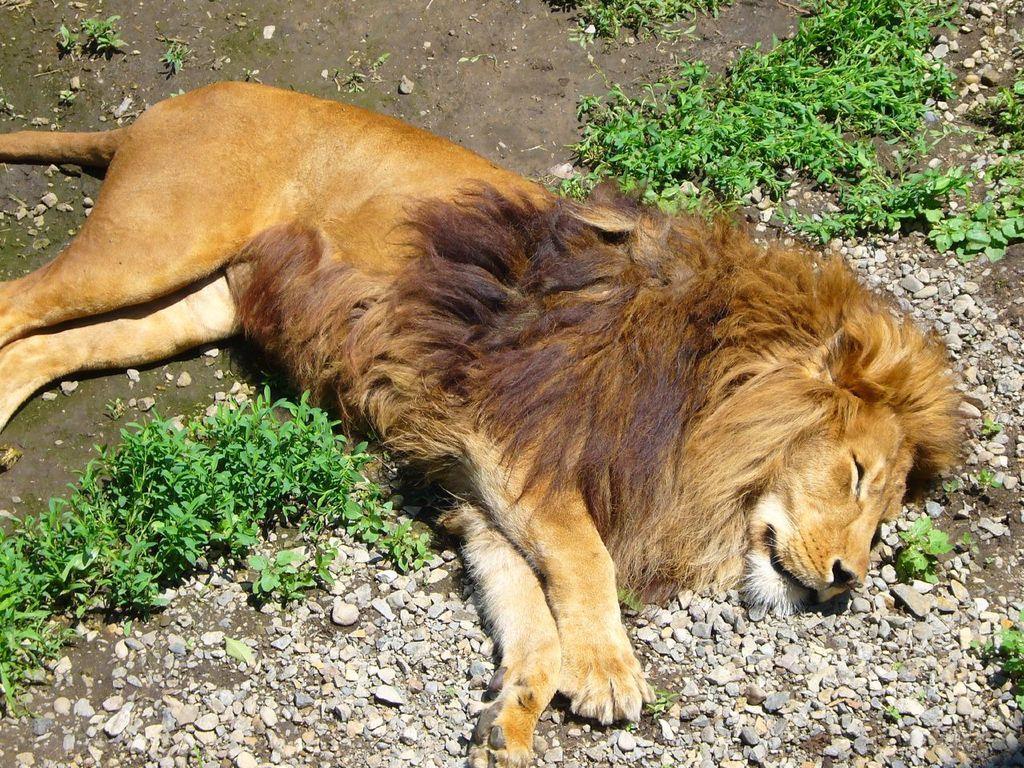How would you summarize this image in a sentence or two? In this image I can see an animal lying on the ground. On the ground I can see the grass and also the rocks. An animal is in brown and black color. 